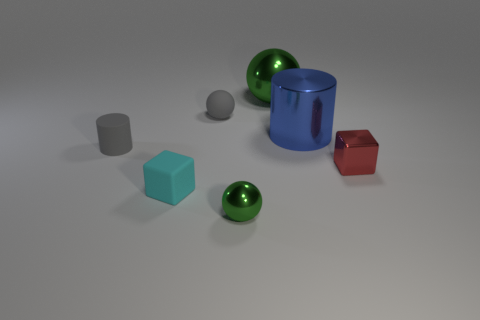Subtract all gray spheres. Subtract all cyan cylinders. How many spheres are left? 2 Subtract all blocks. How many objects are left? 5 Subtract 0 gray cubes. How many objects are left? 7 Subtract all small cylinders. Subtract all tiny gray balls. How many objects are left? 5 Add 3 tiny things. How many tiny things are left? 8 Add 5 tiny cyan objects. How many tiny cyan objects exist? 6 